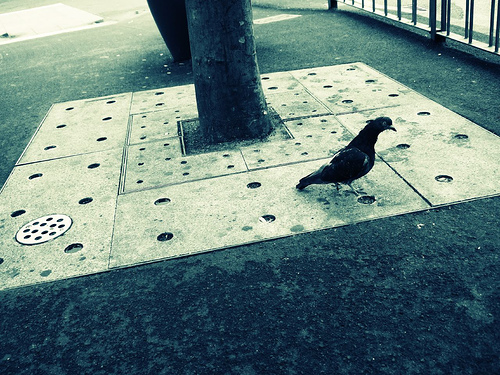<image>
Is there a tree behind the bird? Yes. From this viewpoint, the tree is positioned behind the bird, with the bird partially or fully occluding the tree. Is the pigeon to the right of the drain? Yes. From this viewpoint, the pigeon is positioned to the right side relative to the drain. 